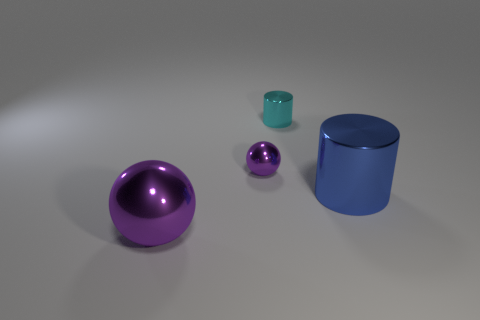Is there anything else that has the same color as the small cylinder?
Keep it short and to the point. No. There is a thing in front of the big blue shiny cylinder; what material is it?
Give a very brief answer. Metal. Does the cyan metal cylinder have the same size as the blue object?
Provide a short and direct response. No. How many other objects are the same size as the blue metallic thing?
Make the answer very short. 1. Do the large sphere and the big cylinder have the same color?
Provide a short and direct response. No. The big object that is behind the object that is in front of the cylinder in front of the tiny cyan thing is what shape?
Provide a succinct answer. Cylinder. What number of things are either metal things that are to the right of the big metal ball or cyan objects right of the big purple shiny sphere?
Ensure brevity in your answer.  3. There is a shiny sphere right of the purple shiny thing that is in front of the tiny purple object; what is its size?
Offer a very short reply. Small. There is a sphere behind the large blue thing; does it have the same color as the big metallic ball?
Provide a short and direct response. Yes. Are there any brown matte objects that have the same shape as the cyan metal thing?
Keep it short and to the point. No. 